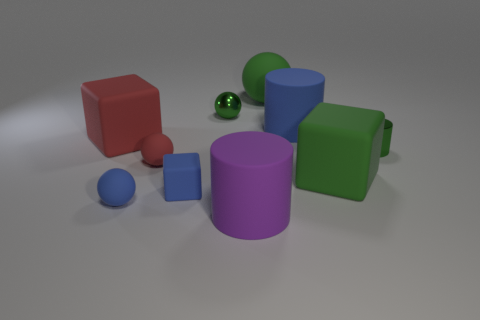Do the large purple object and the big blue matte thing have the same shape?
Your answer should be compact. Yes. How many things are small balls that are behind the big red matte object or big yellow blocks?
Your answer should be very brief. 1. There is a green matte thing behind the large green object in front of the tiny metal object to the left of the tiny green cylinder; what shape is it?
Ensure brevity in your answer.  Sphere. What is the shape of the small red object that is made of the same material as the tiny cube?
Make the answer very short. Sphere. The purple cylinder is what size?
Give a very brief answer. Large. Is the metal sphere the same size as the blue rubber cylinder?
Provide a short and direct response. No. How many objects are tiny objects to the right of the green block or rubber blocks that are right of the large red matte thing?
Provide a succinct answer. 3. How many large red blocks are behind the green metal object left of the blue thing behind the tiny shiny cylinder?
Your answer should be very brief. 0. There is a green sphere that is left of the big green ball; how big is it?
Offer a very short reply. Small. How many blue matte balls have the same size as the green metallic cylinder?
Give a very brief answer. 1. 